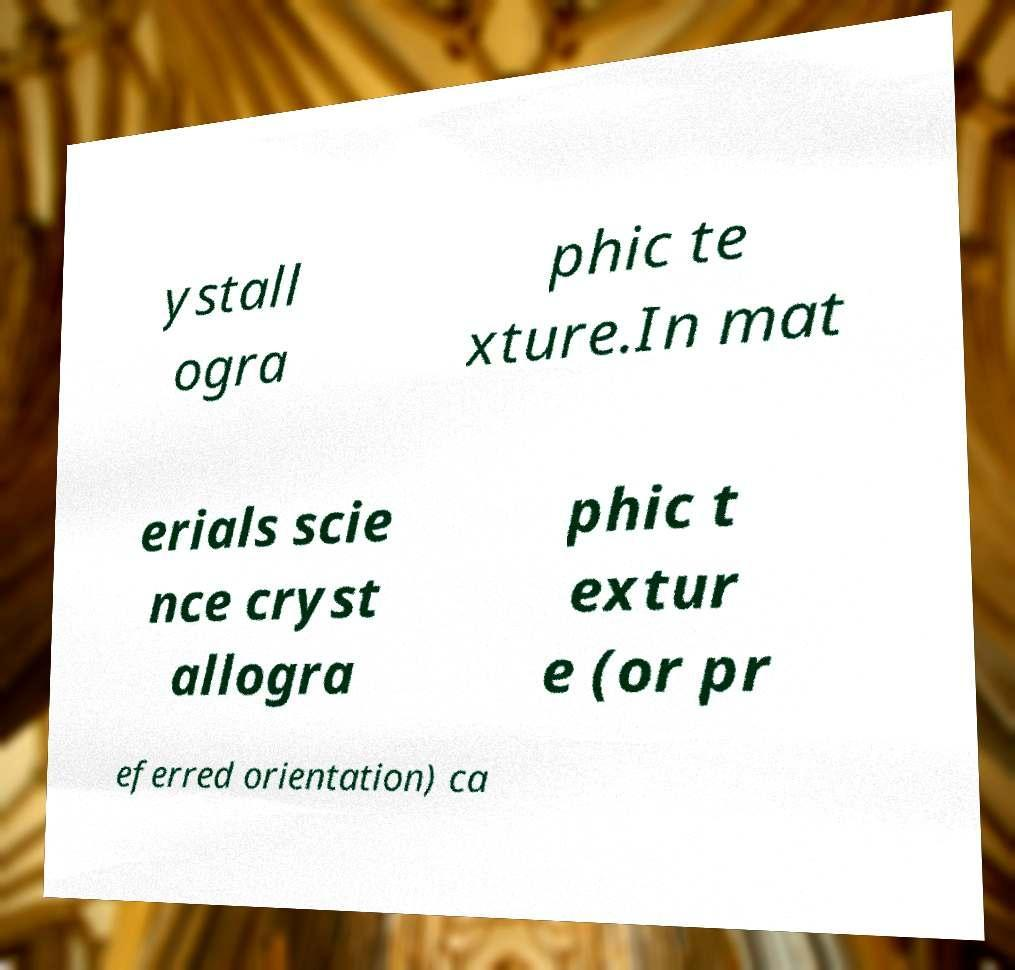I need the written content from this picture converted into text. Can you do that? ystall ogra phic te xture.In mat erials scie nce cryst allogra phic t extur e (or pr eferred orientation) ca 